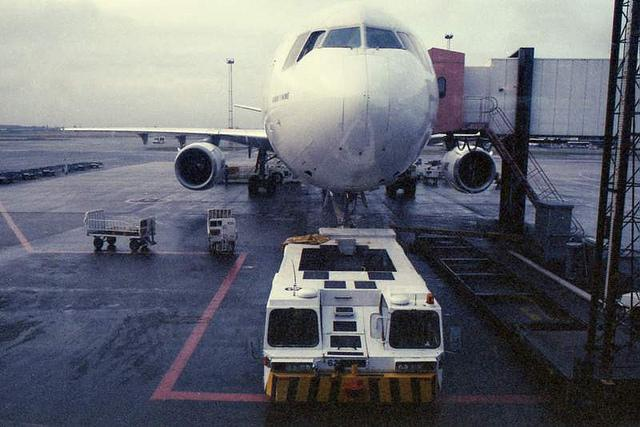The items on the left and right of the front of the biggest vehicle here are called what? Please explain your reasoning. jet engines. These are what powers the vehicle and they are called jet engines. 